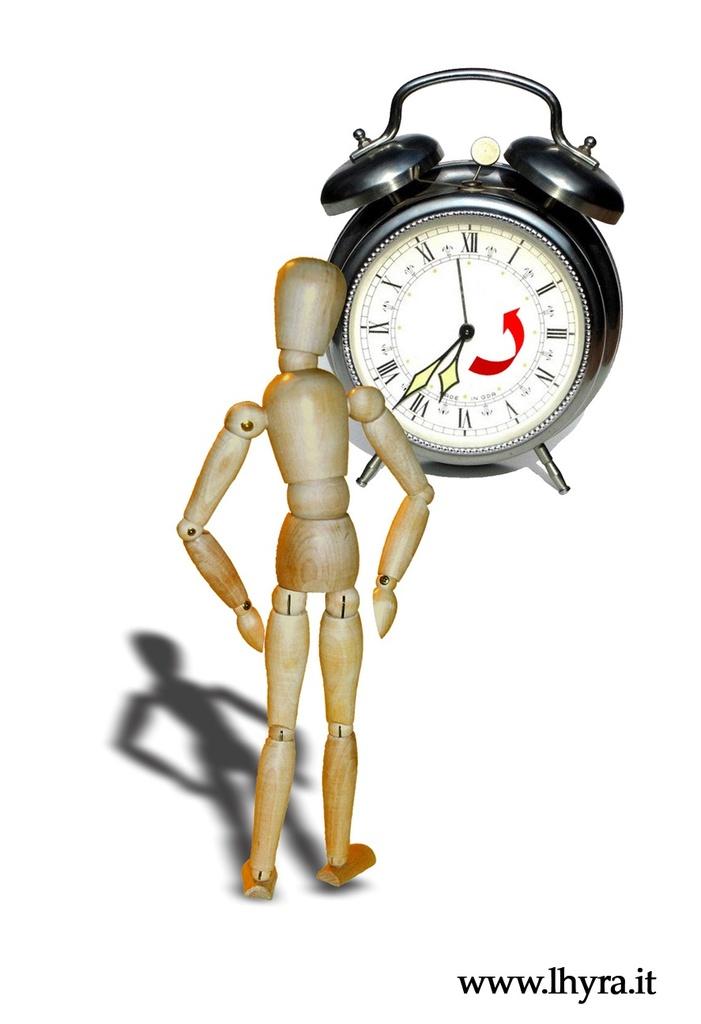What is the time on the clock?
Offer a terse response. 6:37. What is the url at the bottom?
Keep it short and to the point. Www.lhyra.it. 